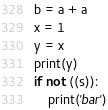<code> <loc_0><loc_0><loc_500><loc_500><_Python_>b = a + a
x = 1
y = x
print(y)
if not ((s)):
    print('bar')
</code> 